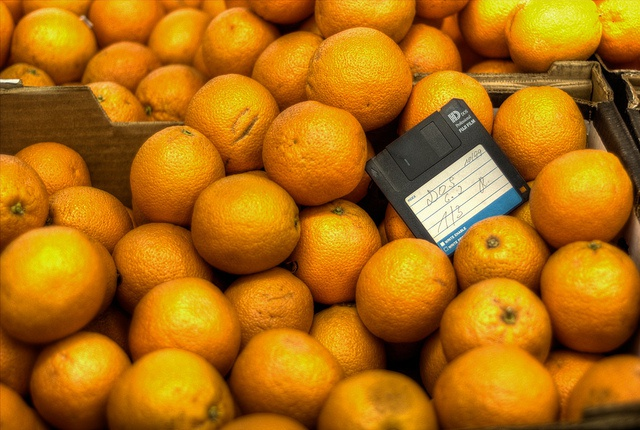Describe the objects in this image and their specific colors. I can see a orange in orange, brown, red, and maroon tones in this image. 